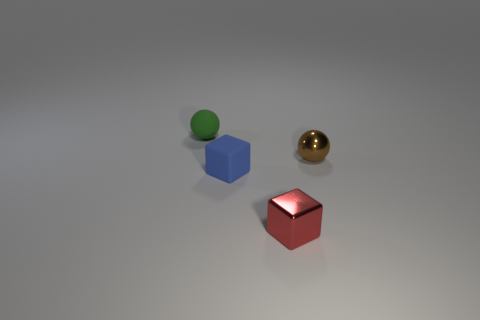Are there more blue rubber objects than cyan cylinders? yes 